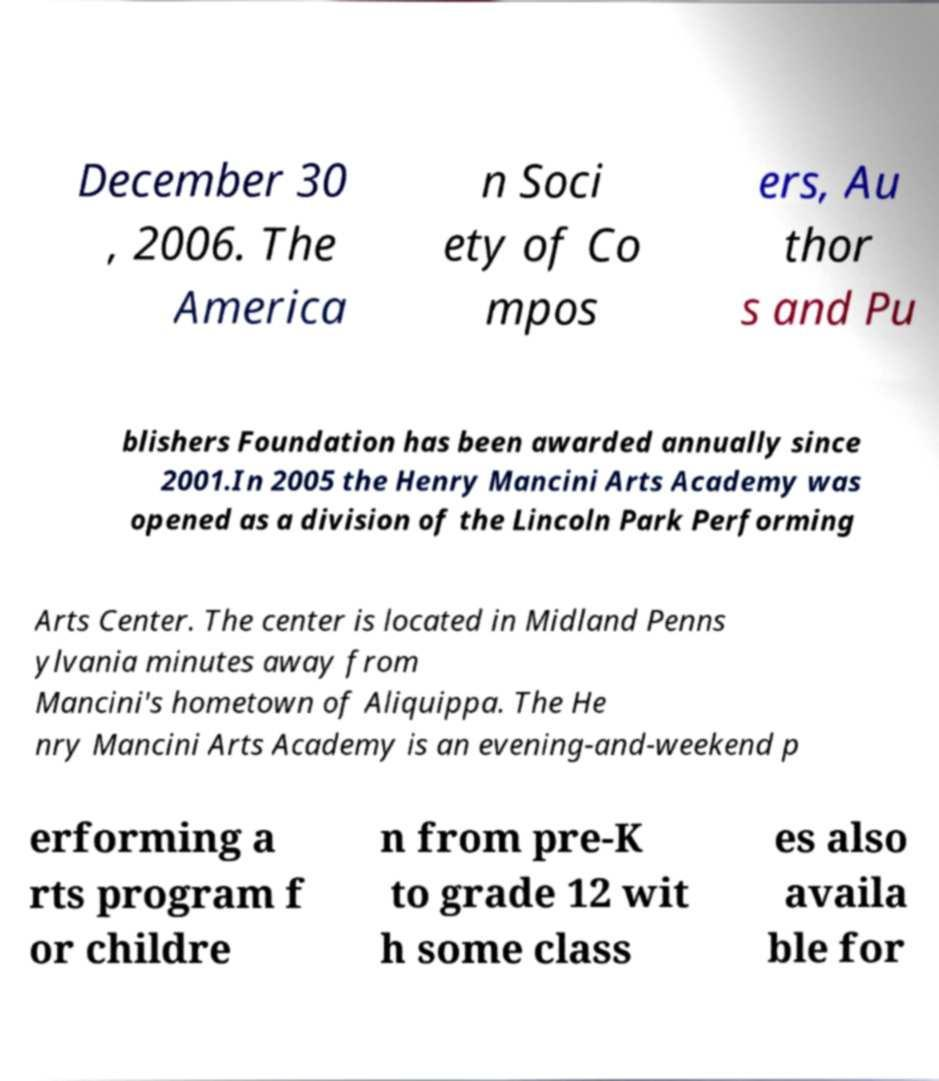Could you extract and type out the text from this image? December 30 , 2006. The America n Soci ety of Co mpos ers, Au thor s and Pu blishers Foundation has been awarded annually since 2001.In 2005 the Henry Mancini Arts Academy was opened as a division of the Lincoln Park Performing Arts Center. The center is located in Midland Penns ylvania minutes away from Mancini's hometown of Aliquippa. The He nry Mancini Arts Academy is an evening-and-weekend p erforming a rts program f or childre n from pre-K to grade 12 wit h some class es also availa ble for 